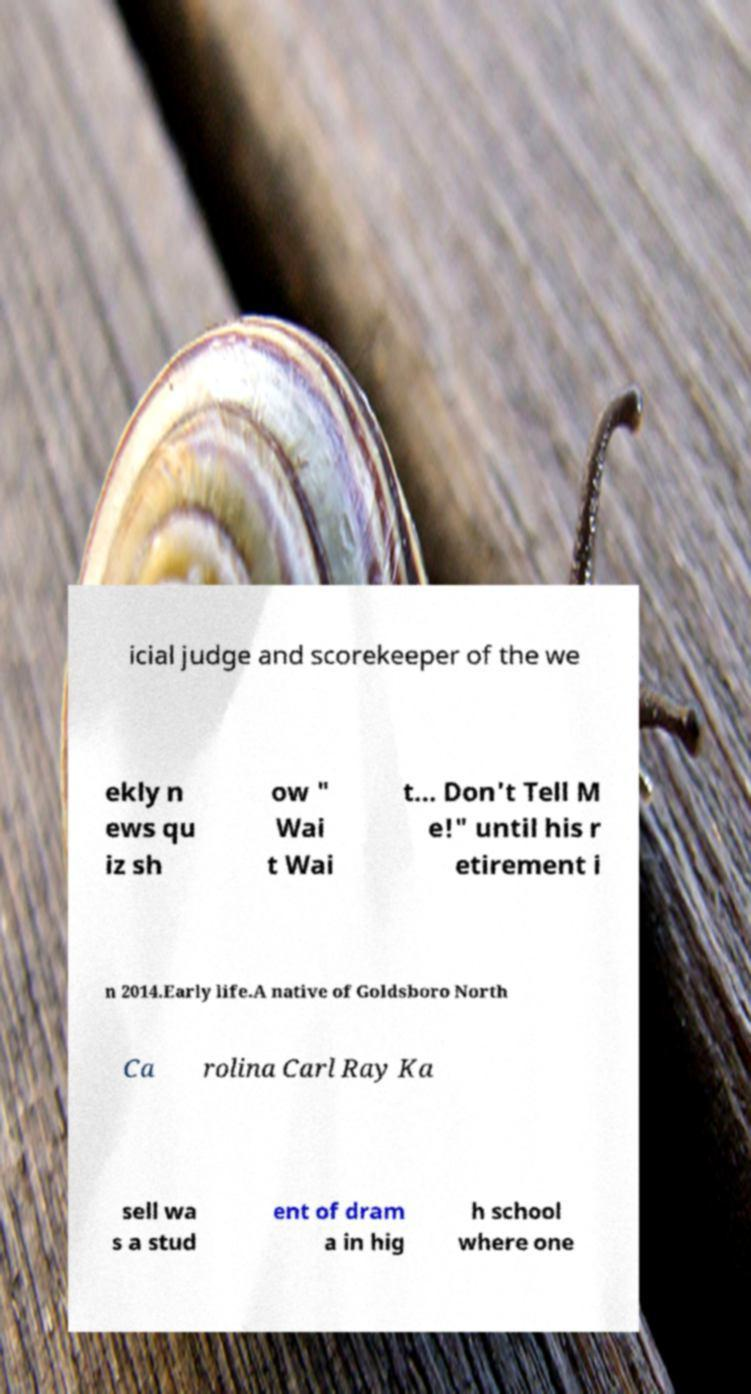What messages or text are displayed in this image? I need them in a readable, typed format. icial judge and scorekeeper of the we ekly n ews qu iz sh ow " Wai t Wai t... Don't Tell M e!" until his r etirement i n 2014.Early life.A native of Goldsboro North Ca rolina Carl Ray Ka sell wa s a stud ent of dram a in hig h school where one 